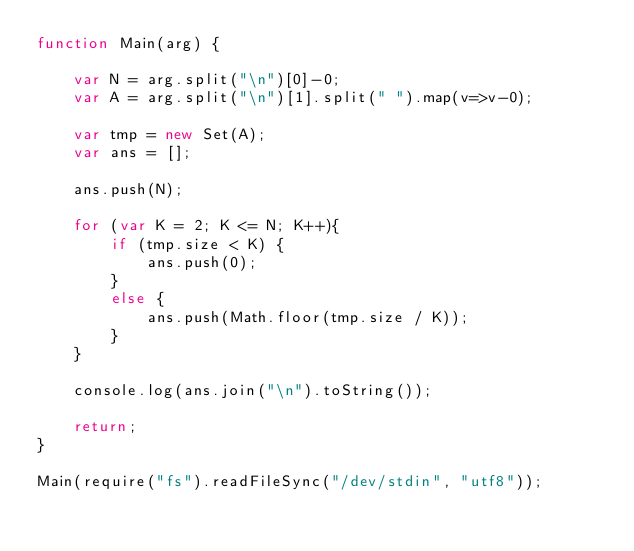<code> <loc_0><loc_0><loc_500><loc_500><_JavaScript_>function Main(arg) {
 
    var N = arg.split("\n")[0]-0;
    var A = arg.split("\n")[1].split(" ").map(v=>v-0);
 
    var tmp = new Set(A);
    var ans = [];

    ans.push(N);

    for (var K = 2; K <= N; K++){
        if (tmp.size < K) {
            ans.push(0);
        }
        else {
            ans.push(Math.floor(tmp.size / K));
        }
    }

    console.log(ans.join("\n").toString());

    return;
}

Main(require("fs").readFileSync("/dev/stdin", "utf8"));</code> 